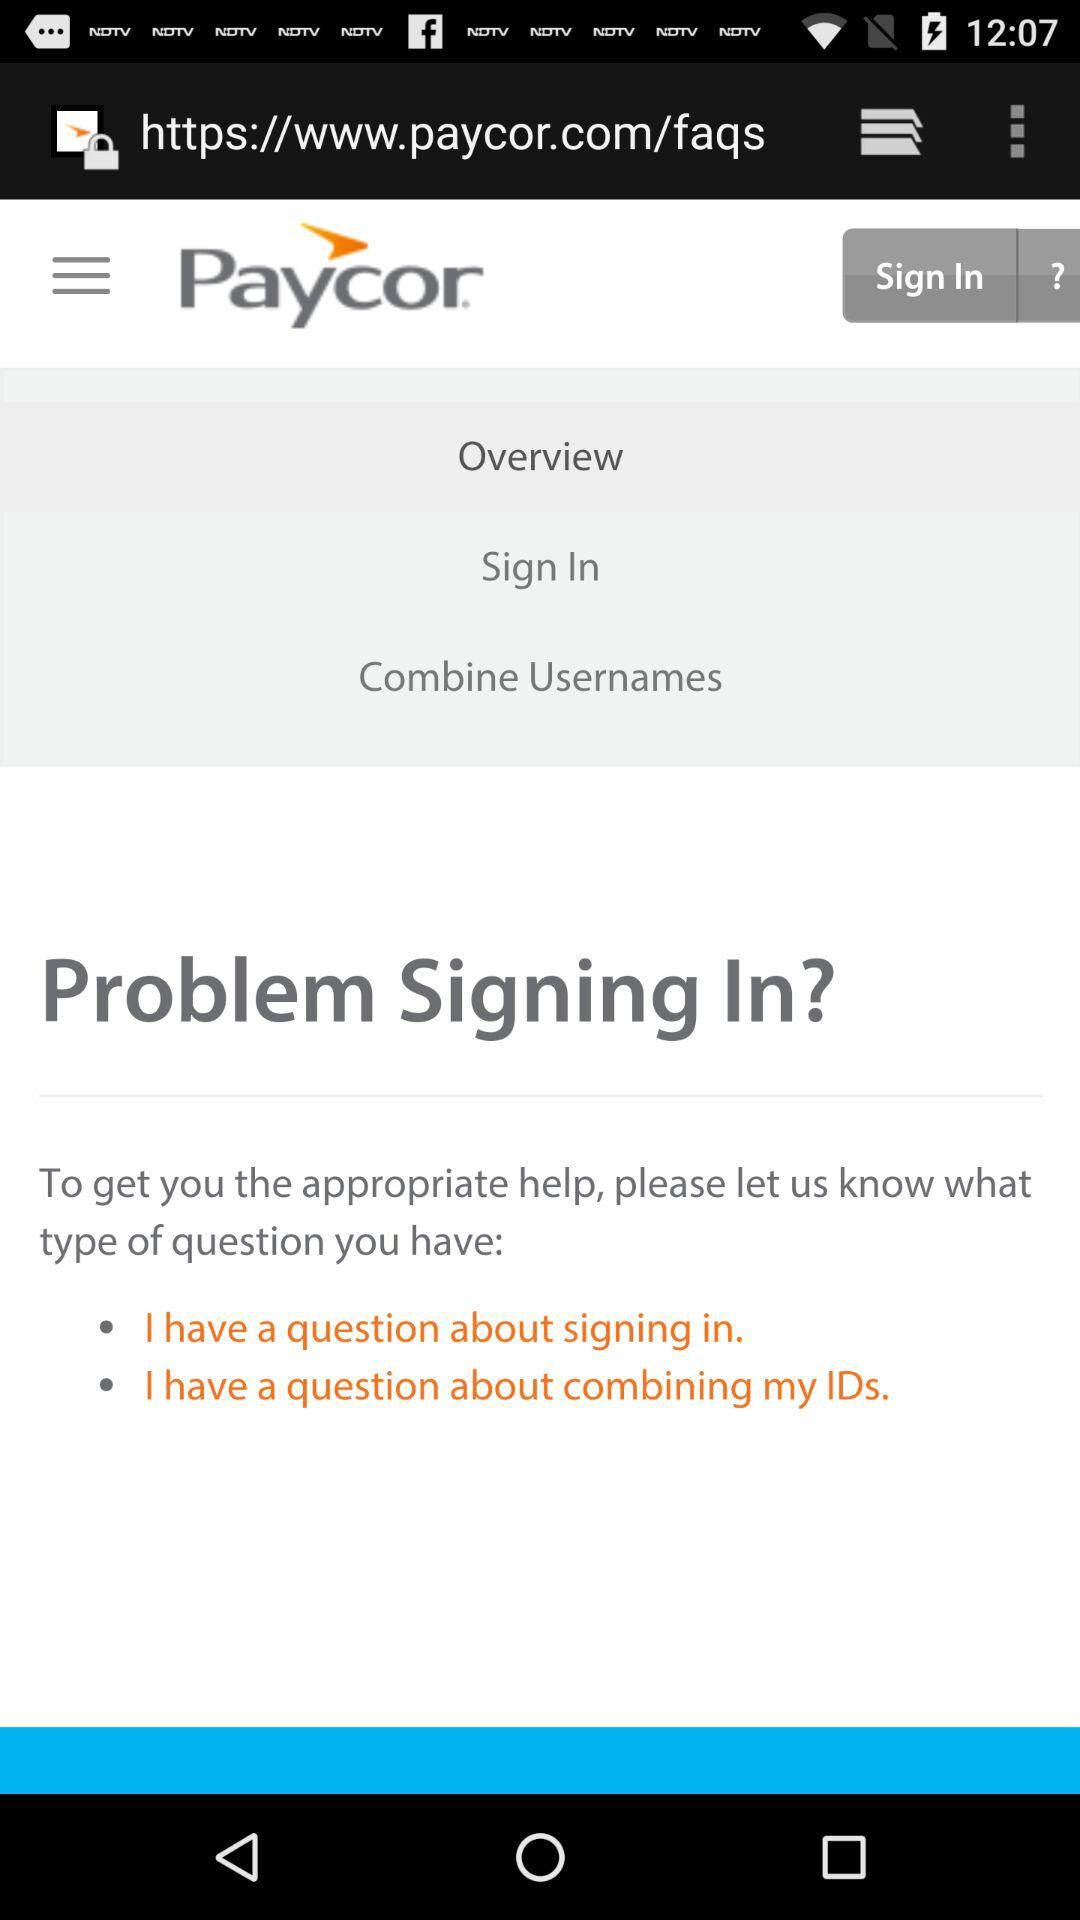How many text elements are there about combining usernames?
Answer the question using a single word or phrase. 1 